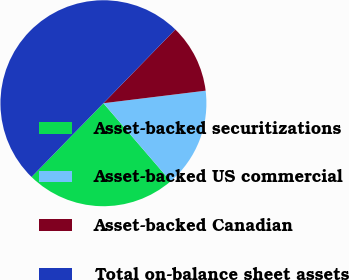Convert chart to OTSL. <chart><loc_0><loc_0><loc_500><loc_500><pie_chart><fcel>Asset-backed securitizations<fcel>Asset-backed US commercial<fcel>Asset-backed Canadian<fcel>Total on-balance sheet assets<nl><fcel>23.61%<fcel>15.63%<fcel>10.76%<fcel>50.0%<nl></chart> 